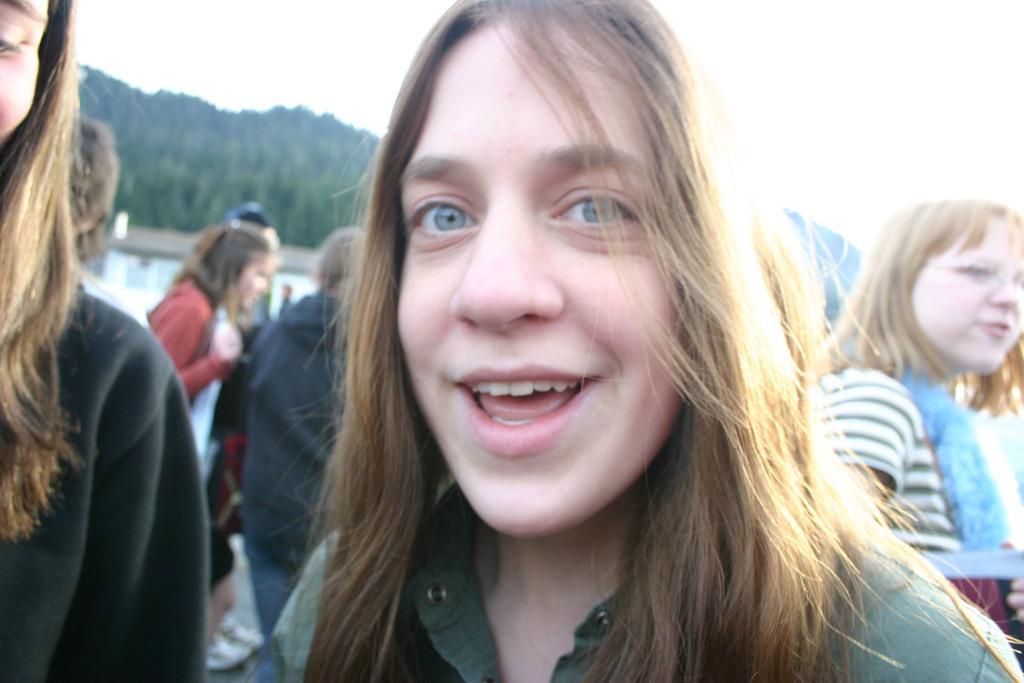Can you describe this image briefly? In this image there are groups of persons standing. In the front there is a person standing and smiling. In the background there are persons and there are trees. 